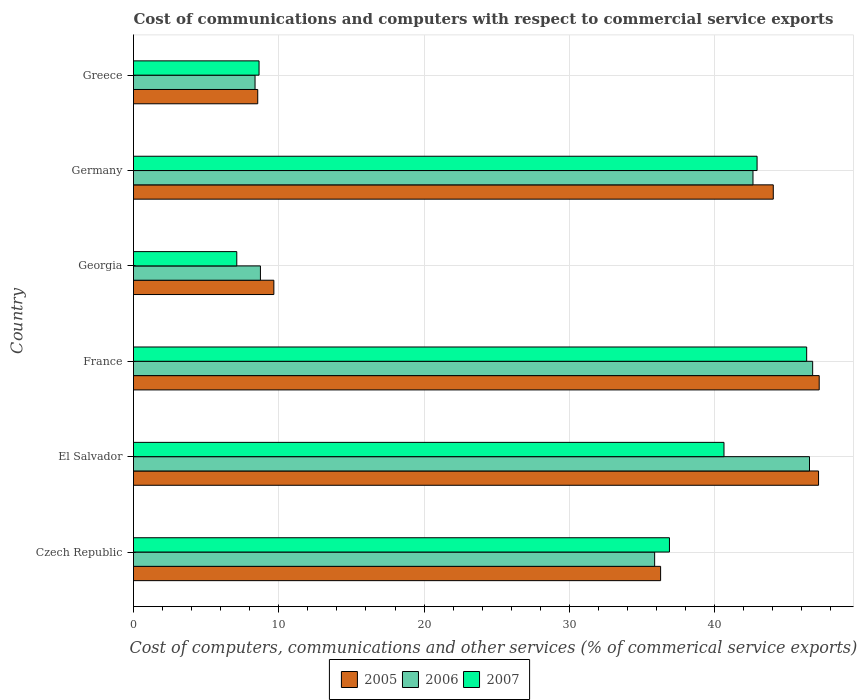Are the number of bars on each tick of the Y-axis equal?
Keep it short and to the point. Yes. How many bars are there on the 6th tick from the top?
Provide a short and direct response. 3. In how many cases, is the number of bars for a given country not equal to the number of legend labels?
Offer a very short reply. 0. What is the cost of communications and computers in 2006 in Georgia?
Your answer should be very brief. 8.74. Across all countries, what is the maximum cost of communications and computers in 2006?
Provide a succinct answer. 46.74. Across all countries, what is the minimum cost of communications and computers in 2005?
Provide a short and direct response. 8.55. In which country was the cost of communications and computers in 2006 minimum?
Your response must be concise. Greece. What is the total cost of communications and computers in 2006 in the graph?
Offer a very short reply. 188.87. What is the difference between the cost of communications and computers in 2006 in El Salvador and that in Georgia?
Provide a short and direct response. 37.79. What is the difference between the cost of communications and computers in 2006 in Greece and the cost of communications and computers in 2005 in France?
Ensure brevity in your answer.  -38.83. What is the average cost of communications and computers in 2006 per country?
Offer a terse response. 31.48. What is the difference between the cost of communications and computers in 2005 and cost of communications and computers in 2006 in Greece?
Ensure brevity in your answer.  0.19. In how many countries, is the cost of communications and computers in 2005 greater than 10 %?
Keep it short and to the point. 4. What is the ratio of the cost of communications and computers in 2006 in France to that in Greece?
Your answer should be compact. 5.59. Is the cost of communications and computers in 2006 in Czech Republic less than that in France?
Provide a succinct answer. Yes. What is the difference between the highest and the second highest cost of communications and computers in 2005?
Offer a terse response. 0.04. What is the difference between the highest and the lowest cost of communications and computers in 2005?
Make the answer very short. 38.64. Is the sum of the cost of communications and computers in 2005 in Georgia and Greece greater than the maximum cost of communications and computers in 2006 across all countries?
Your answer should be very brief. No. What does the 1st bar from the bottom in France represents?
Provide a succinct answer. 2005. How many bars are there?
Offer a very short reply. 18. How many countries are there in the graph?
Give a very brief answer. 6. What is the difference between two consecutive major ticks on the X-axis?
Your response must be concise. 10. Are the values on the major ticks of X-axis written in scientific E-notation?
Provide a succinct answer. No. Does the graph contain any zero values?
Your answer should be very brief. No. How many legend labels are there?
Your response must be concise. 3. How are the legend labels stacked?
Make the answer very short. Horizontal. What is the title of the graph?
Make the answer very short. Cost of communications and computers with respect to commercial service exports. Does "1968" appear as one of the legend labels in the graph?
Ensure brevity in your answer.  No. What is the label or title of the X-axis?
Your answer should be very brief. Cost of computers, communications and other services (% of commerical service exports). What is the Cost of computers, communications and other services (% of commerical service exports) in 2005 in Czech Republic?
Your answer should be very brief. 36.28. What is the Cost of computers, communications and other services (% of commerical service exports) in 2006 in Czech Republic?
Offer a very short reply. 35.87. What is the Cost of computers, communications and other services (% of commerical service exports) of 2007 in Czech Republic?
Give a very brief answer. 36.89. What is the Cost of computers, communications and other services (% of commerical service exports) in 2005 in El Salvador?
Offer a very short reply. 47.15. What is the Cost of computers, communications and other services (% of commerical service exports) of 2006 in El Salvador?
Give a very brief answer. 46.53. What is the Cost of computers, communications and other services (% of commerical service exports) in 2007 in El Salvador?
Give a very brief answer. 40.64. What is the Cost of computers, communications and other services (% of commerical service exports) in 2005 in France?
Offer a very short reply. 47.19. What is the Cost of computers, communications and other services (% of commerical service exports) of 2006 in France?
Your answer should be very brief. 46.74. What is the Cost of computers, communications and other services (% of commerical service exports) in 2007 in France?
Make the answer very short. 46.33. What is the Cost of computers, communications and other services (% of commerical service exports) of 2005 in Georgia?
Keep it short and to the point. 9.66. What is the Cost of computers, communications and other services (% of commerical service exports) of 2006 in Georgia?
Offer a terse response. 8.74. What is the Cost of computers, communications and other services (% of commerical service exports) of 2007 in Georgia?
Offer a terse response. 7.11. What is the Cost of computers, communications and other services (% of commerical service exports) in 2005 in Germany?
Give a very brief answer. 44.03. What is the Cost of computers, communications and other services (% of commerical service exports) in 2006 in Germany?
Keep it short and to the point. 42.64. What is the Cost of computers, communications and other services (% of commerical service exports) in 2007 in Germany?
Provide a succinct answer. 42.92. What is the Cost of computers, communications and other services (% of commerical service exports) in 2005 in Greece?
Make the answer very short. 8.55. What is the Cost of computers, communications and other services (% of commerical service exports) in 2006 in Greece?
Provide a succinct answer. 8.36. What is the Cost of computers, communications and other services (% of commerical service exports) of 2007 in Greece?
Provide a succinct answer. 8.64. Across all countries, what is the maximum Cost of computers, communications and other services (% of commerical service exports) of 2005?
Provide a succinct answer. 47.19. Across all countries, what is the maximum Cost of computers, communications and other services (% of commerical service exports) in 2006?
Give a very brief answer. 46.74. Across all countries, what is the maximum Cost of computers, communications and other services (% of commerical service exports) in 2007?
Your answer should be compact. 46.33. Across all countries, what is the minimum Cost of computers, communications and other services (% of commerical service exports) in 2005?
Give a very brief answer. 8.55. Across all countries, what is the minimum Cost of computers, communications and other services (% of commerical service exports) of 2006?
Provide a short and direct response. 8.36. Across all countries, what is the minimum Cost of computers, communications and other services (% of commerical service exports) of 2007?
Offer a very short reply. 7.11. What is the total Cost of computers, communications and other services (% of commerical service exports) of 2005 in the graph?
Ensure brevity in your answer.  192.87. What is the total Cost of computers, communications and other services (% of commerical service exports) of 2006 in the graph?
Keep it short and to the point. 188.87. What is the total Cost of computers, communications and other services (% of commerical service exports) in 2007 in the graph?
Offer a terse response. 182.53. What is the difference between the Cost of computers, communications and other services (% of commerical service exports) of 2005 in Czech Republic and that in El Salvador?
Provide a short and direct response. -10.87. What is the difference between the Cost of computers, communications and other services (% of commerical service exports) in 2006 in Czech Republic and that in El Salvador?
Your answer should be very brief. -10.66. What is the difference between the Cost of computers, communications and other services (% of commerical service exports) of 2007 in Czech Republic and that in El Salvador?
Keep it short and to the point. -3.75. What is the difference between the Cost of computers, communications and other services (% of commerical service exports) of 2005 in Czech Republic and that in France?
Give a very brief answer. -10.92. What is the difference between the Cost of computers, communications and other services (% of commerical service exports) in 2006 in Czech Republic and that in France?
Provide a succinct answer. -10.88. What is the difference between the Cost of computers, communications and other services (% of commerical service exports) of 2007 in Czech Republic and that in France?
Your answer should be compact. -9.44. What is the difference between the Cost of computers, communications and other services (% of commerical service exports) of 2005 in Czech Republic and that in Georgia?
Offer a very short reply. 26.62. What is the difference between the Cost of computers, communications and other services (% of commerical service exports) in 2006 in Czech Republic and that in Georgia?
Keep it short and to the point. 27.13. What is the difference between the Cost of computers, communications and other services (% of commerical service exports) of 2007 in Czech Republic and that in Georgia?
Provide a succinct answer. 29.78. What is the difference between the Cost of computers, communications and other services (% of commerical service exports) of 2005 in Czech Republic and that in Germany?
Offer a very short reply. -7.75. What is the difference between the Cost of computers, communications and other services (% of commerical service exports) in 2006 in Czech Republic and that in Germany?
Offer a very short reply. -6.77. What is the difference between the Cost of computers, communications and other services (% of commerical service exports) in 2007 in Czech Republic and that in Germany?
Your answer should be very brief. -6.03. What is the difference between the Cost of computers, communications and other services (% of commerical service exports) of 2005 in Czech Republic and that in Greece?
Your response must be concise. 27.73. What is the difference between the Cost of computers, communications and other services (% of commerical service exports) of 2006 in Czech Republic and that in Greece?
Your answer should be compact. 27.5. What is the difference between the Cost of computers, communications and other services (% of commerical service exports) in 2007 in Czech Republic and that in Greece?
Ensure brevity in your answer.  28.25. What is the difference between the Cost of computers, communications and other services (% of commerical service exports) of 2005 in El Salvador and that in France?
Ensure brevity in your answer.  -0.04. What is the difference between the Cost of computers, communications and other services (% of commerical service exports) in 2006 in El Salvador and that in France?
Make the answer very short. -0.22. What is the difference between the Cost of computers, communications and other services (% of commerical service exports) in 2007 in El Salvador and that in France?
Offer a terse response. -5.69. What is the difference between the Cost of computers, communications and other services (% of commerical service exports) of 2005 in El Salvador and that in Georgia?
Offer a terse response. 37.49. What is the difference between the Cost of computers, communications and other services (% of commerical service exports) in 2006 in El Salvador and that in Georgia?
Keep it short and to the point. 37.79. What is the difference between the Cost of computers, communications and other services (% of commerical service exports) in 2007 in El Salvador and that in Georgia?
Keep it short and to the point. 33.53. What is the difference between the Cost of computers, communications and other services (% of commerical service exports) in 2005 in El Salvador and that in Germany?
Give a very brief answer. 3.12. What is the difference between the Cost of computers, communications and other services (% of commerical service exports) of 2006 in El Salvador and that in Germany?
Your response must be concise. 3.89. What is the difference between the Cost of computers, communications and other services (% of commerical service exports) of 2007 in El Salvador and that in Germany?
Your answer should be compact. -2.28. What is the difference between the Cost of computers, communications and other services (% of commerical service exports) of 2005 in El Salvador and that in Greece?
Provide a succinct answer. 38.6. What is the difference between the Cost of computers, communications and other services (% of commerical service exports) in 2006 in El Salvador and that in Greece?
Your answer should be very brief. 38.16. What is the difference between the Cost of computers, communications and other services (% of commerical service exports) in 2007 in El Salvador and that in Greece?
Keep it short and to the point. 32. What is the difference between the Cost of computers, communications and other services (% of commerical service exports) in 2005 in France and that in Georgia?
Provide a succinct answer. 37.53. What is the difference between the Cost of computers, communications and other services (% of commerical service exports) in 2006 in France and that in Georgia?
Your answer should be compact. 38.01. What is the difference between the Cost of computers, communications and other services (% of commerical service exports) of 2007 in France and that in Georgia?
Ensure brevity in your answer.  39.22. What is the difference between the Cost of computers, communications and other services (% of commerical service exports) in 2005 in France and that in Germany?
Give a very brief answer. 3.16. What is the difference between the Cost of computers, communications and other services (% of commerical service exports) of 2006 in France and that in Germany?
Provide a short and direct response. 4.11. What is the difference between the Cost of computers, communications and other services (% of commerical service exports) in 2007 in France and that in Germany?
Your response must be concise. 3.41. What is the difference between the Cost of computers, communications and other services (% of commerical service exports) of 2005 in France and that in Greece?
Offer a very short reply. 38.64. What is the difference between the Cost of computers, communications and other services (% of commerical service exports) of 2006 in France and that in Greece?
Your answer should be compact. 38.38. What is the difference between the Cost of computers, communications and other services (% of commerical service exports) of 2007 in France and that in Greece?
Provide a short and direct response. 37.69. What is the difference between the Cost of computers, communications and other services (% of commerical service exports) in 2005 in Georgia and that in Germany?
Offer a terse response. -34.37. What is the difference between the Cost of computers, communications and other services (% of commerical service exports) of 2006 in Georgia and that in Germany?
Provide a succinct answer. -33.9. What is the difference between the Cost of computers, communications and other services (% of commerical service exports) of 2007 in Georgia and that in Germany?
Give a very brief answer. -35.81. What is the difference between the Cost of computers, communications and other services (% of commerical service exports) of 2005 in Georgia and that in Greece?
Your response must be concise. 1.11. What is the difference between the Cost of computers, communications and other services (% of commerical service exports) in 2006 in Georgia and that in Greece?
Keep it short and to the point. 0.37. What is the difference between the Cost of computers, communications and other services (% of commerical service exports) of 2007 in Georgia and that in Greece?
Ensure brevity in your answer.  -1.53. What is the difference between the Cost of computers, communications and other services (% of commerical service exports) of 2005 in Germany and that in Greece?
Keep it short and to the point. 35.48. What is the difference between the Cost of computers, communications and other services (% of commerical service exports) of 2006 in Germany and that in Greece?
Offer a terse response. 34.27. What is the difference between the Cost of computers, communications and other services (% of commerical service exports) in 2007 in Germany and that in Greece?
Give a very brief answer. 34.28. What is the difference between the Cost of computers, communications and other services (% of commerical service exports) in 2005 in Czech Republic and the Cost of computers, communications and other services (% of commerical service exports) in 2006 in El Salvador?
Make the answer very short. -10.25. What is the difference between the Cost of computers, communications and other services (% of commerical service exports) of 2005 in Czech Republic and the Cost of computers, communications and other services (% of commerical service exports) of 2007 in El Salvador?
Offer a very short reply. -4.36. What is the difference between the Cost of computers, communications and other services (% of commerical service exports) of 2006 in Czech Republic and the Cost of computers, communications and other services (% of commerical service exports) of 2007 in El Salvador?
Offer a very short reply. -4.77. What is the difference between the Cost of computers, communications and other services (% of commerical service exports) in 2005 in Czech Republic and the Cost of computers, communications and other services (% of commerical service exports) in 2006 in France?
Your response must be concise. -10.46. What is the difference between the Cost of computers, communications and other services (% of commerical service exports) of 2005 in Czech Republic and the Cost of computers, communications and other services (% of commerical service exports) of 2007 in France?
Your answer should be very brief. -10.05. What is the difference between the Cost of computers, communications and other services (% of commerical service exports) of 2006 in Czech Republic and the Cost of computers, communications and other services (% of commerical service exports) of 2007 in France?
Your answer should be very brief. -10.46. What is the difference between the Cost of computers, communications and other services (% of commerical service exports) in 2005 in Czech Republic and the Cost of computers, communications and other services (% of commerical service exports) in 2006 in Georgia?
Make the answer very short. 27.54. What is the difference between the Cost of computers, communications and other services (% of commerical service exports) in 2005 in Czech Republic and the Cost of computers, communications and other services (% of commerical service exports) in 2007 in Georgia?
Make the answer very short. 29.17. What is the difference between the Cost of computers, communications and other services (% of commerical service exports) in 2006 in Czech Republic and the Cost of computers, communications and other services (% of commerical service exports) in 2007 in Georgia?
Provide a succinct answer. 28.76. What is the difference between the Cost of computers, communications and other services (% of commerical service exports) in 2005 in Czech Republic and the Cost of computers, communications and other services (% of commerical service exports) in 2006 in Germany?
Ensure brevity in your answer.  -6.36. What is the difference between the Cost of computers, communications and other services (% of commerical service exports) in 2005 in Czech Republic and the Cost of computers, communications and other services (% of commerical service exports) in 2007 in Germany?
Provide a short and direct response. -6.64. What is the difference between the Cost of computers, communications and other services (% of commerical service exports) of 2006 in Czech Republic and the Cost of computers, communications and other services (% of commerical service exports) of 2007 in Germany?
Your answer should be very brief. -7.05. What is the difference between the Cost of computers, communications and other services (% of commerical service exports) in 2005 in Czech Republic and the Cost of computers, communications and other services (% of commerical service exports) in 2006 in Greece?
Provide a short and direct response. 27.91. What is the difference between the Cost of computers, communications and other services (% of commerical service exports) in 2005 in Czech Republic and the Cost of computers, communications and other services (% of commerical service exports) in 2007 in Greece?
Provide a short and direct response. 27.64. What is the difference between the Cost of computers, communications and other services (% of commerical service exports) of 2006 in Czech Republic and the Cost of computers, communications and other services (% of commerical service exports) of 2007 in Greece?
Your response must be concise. 27.23. What is the difference between the Cost of computers, communications and other services (% of commerical service exports) of 2005 in El Salvador and the Cost of computers, communications and other services (% of commerical service exports) of 2006 in France?
Offer a very short reply. 0.41. What is the difference between the Cost of computers, communications and other services (% of commerical service exports) of 2005 in El Salvador and the Cost of computers, communications and other services (% of commerical service exports) of 2007 in France?
Provide a succinct answer. 0.82. What is the difference between the Cost of computers, communications and other services (% of commerical service exports) of 2006 in El Salvador and the Cost of computers, communications and other services (% of commerical service exports) of 2007 in France?
Ensure brevity in your answer.  0.19. What is the difference between the Cost of computers, communications and other services (% of commerical service exports) in 2005 in El Salvador and the Cost of computers, communications and other services (% of commerical service exports) in 2006 in Georgia?
Ensure brevity in your answer.  38.41. What is the difference between the Cost of computers, communications and other services (% of commerical service exports) in 2005 in El Salvador and the Cost of computers, communications and other services (% of commerical service exports) in 2007 in Georgia?
Keep it short and to the point. 40.04. What is the difference between the Cost of computers, communications and other services (% of commerical service exports) of 2006 in El Salvador and the Cost of computers, communications and other services (% of commerical service exports) of 2007 in Georgia?
Offer a terse response. 39.42. What is the difference between the Cost of computers, communications and other services (% of commerical service exports) of 2005 in El Salvador and the Cost of computers, communications and other services (% of commerical service exports) of 2006 in Germany?
Your answer should be very brief. 4.51. What is the difference between the Cost of computers, communications and other services (% of commerical service exports) in 2005 in El Salvador and the Cost of computers, communications and other services (% of commerical service exports) in 2007 in Germany?
Ensure brevity in your answer.  4.23. What is the difference between the Cost of computers, communications and other services (% of commerical service exports) of 2006 in El Salvador and the Cost of computers, communications and other services (% of commerical service exports) of 2007 in Germany?
Your answer should be very brief. 3.61. What is the difference between the Cost of computers, communications and other services (% of commerical service exports) of 2005 in El Salvador and the Cost of computers, communications and other services (% of commerical service exports) of 2006 in Greece?
Offer a very short reply. 38.78. What is the difference between the Cost of computers, communications and other services (% of commerical service exports) of 2005 in El Salvador and the Cost of computers, communications and other services (% of commerical service exports) of 2007 in Greece?
Your answer should be compact. 38.51. What is the difference between the Cost of computers, communications and other services (% of commerical service exports) of 2006 in El Salvador and the Cost of computers, communications and other services (% of commerical service exports) of 2007 in Greece?
Your response must be concise. 37.89. What is the difference between the Cost of computers, communications and other services (% of commerical service exports) of 2005 in France and the Cost of computers, communications and other services (% of commerical service exports) of 2006 in Georgia?
Your response must be concise. 38.46. What is the difference between the Cost of computers, communications and other services (% of commerical service exports) of 2005 in France and the Cost of computers, communications and other services (% of commerical service exports) of 2007 in Georgia?
Make the answer very short. 40.09. What is the difference between the Cost of computers, communications and other services (% of commerical service exports) of 2006 in France and the Cost of computers, communications and other services (% of commerical service exports) of 2007 in Georgia?
Your answer should be very brief. 39.64. What is the difference between the Cost of computers, communications and other services (% of commerical service exports) of 2005 in France and the Cost of computers, communications and other services (% of commerical service exports) of 2006 in Germany?
Your response must be concise. 4.56. What is the difference between the Cost of computers, communications and other services (% of commerical service exports) in 2005 in France and the Cost of computers, communications and other services (% of commerical service exports) in 2007 in Germany?
Ensure brevity in your answer.  4.28. What is the difference between the Cost of computers, communications and other services (% of commerical service exports) in 2006 in France and the Cost of computers, communications and other services (% of commerical service exports) in 2007 in Germany?
Offer a very short reply. 3.83. What is the difference between the Cost of computers, communications and other services (% of commerical service exports) of 2005 in France and the Cost of computers, communications and other services (% of commerical service exports) of 2006 in Greece?
Make the answer very short. 38.83. What is the difference between the Cost of computers, communications and other services (% of commerical service exports) in 2005 in France and the Cost of computers, communications and other services (% of commerical service exports) in 2007 in Greece?
Your answer should be compact. 38.55. What is the difference between the Cost of computers, communications and other services (% of commerical service exports) in 2006 in France and the Cost of computers, communications and other services (% of commerical service exports) in 2007 in Greece?
Keep it short and to the point. 38.1. What is the difference between the Cost of computers, communications and other services (% of commerical service exports) of 2005 in Georgia and the Cost of computers, communications and other services (% of commerical service exports) of 2006 in Germany?
Ensure brevity in your answer.  -32.98. What is the difference between the Cost of computers, communications and other services (% of commerical service exports) of 2005 in Georgia and the Cost of computers, communications and other services (% of commerical service exports) of 2007 in Germany?
Your answer should be very brief. -33.26. What is the difference between the Cost of computers, communications and other services (% of commerical service exports) of 2006 in Georgia and the Cost of computers, communications and other services (% of commerical service exports) of 2007 in Germany?
Make the answer very short. -34.18. What is the difference between the Cost of computers, communications and other services (% of commerical service exports) of 2005 in Georgia and the Cost of computers, communications and other services (% of commerical service exports) of 2006 in Greece?
Your response must be concise. 1.3. What is the difference between the Cost of computers, communications and other services (% of commerical service exports) of 2005 in Georgia and the Cost of computers, communications and other services (% of commerical service exports) of 2007 in Greece?
Make the answer very short. 1.02. What is the difference between the Cost of computers, communications and other services (% of commerical service exports) of 2006 in Georgia and the Cost of computers, communications and other services (% of commerical service exports) of 2007 in Greece?
Your response must be concise. 0.1. What is the difference between the Cost of computers, communications and other services (% of commerical service exports) in 2005 in Germany and the Cost of computers, communications and other services (% of commerical service exports) in 2006 in Greece?
Make the answer very short. 35.67. What is the difference between the Cost of computers, communications and other services (% of commerical service exports) of 2005 in Germany and the Cost of computers, communications and other services (% of commerical service exports) of 2007 in Greece?
Your response must be concise. 35.39. What is the difference between the Cost of computers, communications and other services (% of commerical service exports) in 2006 in Germany and the Cost of computers, communications and other services (% of commerical service exports) in 2007 in Greece?
Provide a short and direct response. 34. What is the average Cost of computers, communications and other services (% of commerical service exports) of 2005 per country?
Ensure brevity in your answer.  32.14. What is the average Cost of computers, communications and other services (% of commerical service exports) of 2006 per country?
Offer a terse response. 31.48. What is the average Cost of computers, communications and other services (% of commerical service exports) of 2007 per country?
Make the answer very short. 30.42. What is the difference between the Cost of computers, communications and other services (% of commerical service exports) of 2005 and Cost of computers, communications and other services (% of commerical service exports) of 2006 in Czech Republic?
Provide a short and direct response. 0.41. What is the difference between the Cost of computers, communications and other services (% of commerical service exports) in 2005 and Cost of computers, communications and other services (% of commerical service exports) in 2007 in Czech Republic?
Your answer should be compact. -0.61. What is the difference between the Cost of computers, communications and other services (% of commerical service exports) in 2006 and Cost of computers, communications and other services (% of commerical service exports) in 2007 in Czech Republic?
Your response must be concise. -1.02. What is the difference between the Cost of computers, communications and other services (% of commerical service exports) in 2005 and Cost of computers, communications and other services (% of commerical service exports) in 2006 in El Salvador?
Your response must be concise. 0.62. What is the difference between the Cost of computers, communications and other services (% of commerical service exports) of 2005 and Cost of computers, communications and other services (% of commerical service exports) of 2007 in El Salvador?
Offer a very short reply. 6.51. What is the difference between the Cost of computers, communications and other services (% of commerical service exports) in 2006 and Cost of computers, communications and other services (% of commerical service exports) in 2007 in El Salvador?
Offer a very short reply. 5.89. What is the difference between the Cost of computers, communications and other services (% of commerical service exports) in 2005 and Cost of computers, communications and other services (% of commerical service exports) in 2006 in France?
Give a very brief answer. 0.45. What is the difference between the Cost of computers, communications and other services (% of commerical service exports) of 2005 and Cost of computers, communications and other services (% of commerical service exports) of 2007 in France?
Your answer should be compact. 0.86. What is the difference between the Cost of computers, communications and other services (% of commerical service exports) in 2006 and Cost of computers, communications and other services (% of commerical service exports) in 2007 in France?
Offer a terse response. 0.41. What is the difference between the Cost of computers, communications and other services (% of commerical service exports) in 2005 and Cost of computers, communications and other services (% of commerical service exports) in 2006 in Georgia?
Provide a succinct answer. 0.93. What is the difference between the Cost of computers, communications and other services (% of commerical service exports) of 2005 and Cost of computers, communications and other services (% of commerical service exports) of 2007 in Georgia?
Ensure brevity in your answer.  2.55. What is the difference between the Cost of computers, communications and other services (% of commerical service exports) of 2006 and Cost of computers, communications and other services (% of commerical service exports) of 2007 in Georgia?
Ensure brevity in your answer.  1.63. What is the difference between the Cost of computers, communications and other services (% of commerical service exports) of 2005 and Cost of computers, communications and other services (% of commerical service exports) of 2006 in Germany?
Keep it short and to the point. 1.4. What is the difference between the Cost of computers, communications and other services (% of commerical service exports) of 2005 and Cost of computers, communications and other services (% of commerical service exports) of 2007 in Germany?
Offer a terse response. 1.11. What is the difference between the Cost of computers, communications and other services (% of commerical service exports) of 2006 and Cost of computers, communications and other services (% of commerical service exports) of 2007 in Germany?
Your answer should be compact. -0.28. What is the difference between the Cost of computers, communications and other services (% of commerical service exports) in 2005 and Cost of computers, communications and other services (% of commerical service exports) in 2006 in Greece?
Your response must be concise. 0.19. What is the difference between the Cost of computers, communications and other services (% of commerical service exports) in 2005 and Cost of computers, communications and other services (% of commerical service exports) in 2007 in Greece?
Ensure brevity in your answer.  -0.09. What is the difference between the Cost of computers, communications and other services (% of commerical service exports) of 2006 and Cost of computers, communications and other services (% of commerical service exports) of 2007 in Greece?
Give a very brief answer. -0.28. What is the ratio of the Cost of computers, communications and other services (% of commerical service exports) of 2005 in Czech Republic to that in El Salvador?
Provide a succinct answer. 0.77. What is the ratio of the Cost of computers, communications and other services (% of commerical service exports) of 2006 in Czech Republic to that in El Salvador?
Ensure brevity in your answer.  0.77. What is the ratio of the Cost of computers, communications and other services (% of commerical service exports) of 2007 in Czech Republic to that in El Salvador?
Provide a short and direct response. 0.91. What is the ratio of the Cost of computers, communications and other services (% of commerical service exports) in 2005 in Czech Republic to that in France?
Your response must be concise. 0.77. What is the ratio of the Cost of computers, communications and other services (% of commerical service exports) of 2006 in Czech Republic to that in France?
Offer a terse response. 0.77. What is the ratio of the Cost of computers, communications and other services (% of commerical service exports) in 2007 in Czech Republic to that in France?
Make the answer very short. 0.8. What is the ratio of the Cost of computers, communications and other services (% of commerical service exports) in 2005 in Czech Republic to that in Georgia?
Give a very brief answer. 3.76. What is the ratio of the Cost of computers, communications and other services (% of commerical service exports) of 2006 in Czech Republic to that in Georgia?
Ensure brevity in your answer.  4.11. What is the ratio of the Cost of computers, communications and other services (% of commerical service exports) of 2007 in Czech Republic to that in Georgia?
Your response must be concise. 5.19. What is the ratio of the Cost of computers, communications and other services (% of commerical service exports) of 2005 in Czech Republic to that in Germany?
Keep it short and to the point. 0.82. What is the ratio of the Cost of computers, communications and other services (% of commerical service exports) in 2006 in Czech Republic to that in Germany?
Provide a short and direct response. 0.84. What is the ratio of the Cost of computers, communications and other services (% of commerical service exports) in 2007 in Czech Republic to that in Germany?
Keep it short and to the point. 0.86. What is the ratio of the Cost of computers, communications and other services (% of commerical service exports) of 2005 in Czech Republic to that in Greece?
Give a very brief answer. 4.24. What is the ratio of the Cost of computers, communications and other services (% of commerical service exports) of 2006 in Czech Republic to that in Greece?
Provide a short and direct response. 4.29. What is the ratio of the Cost of computers, communications and other services (% of commerical service exports) of 2007 in Czech Republic to that in Greece?
Provide a succinct answer. 4.27. What is the ratio of the Cost of computers, communications and other services (% of commerical service exports) in 2005 in El Salvador to that in France?
Offer a terse response. 1. What is the ratio of the Cost of computers, communications and other services (% of commerical service exports) of 2006 in El Salvador to that in France?
Offer a very short reply. 1. What is the ratio of the Cost of computers, communications and other services (% of commerical service exports) of 2007 in El Salvador to that in France?
Give a very brief answer. 0.88. What is the ratio of the Cost of computers, communications and other services (% of commerical service exports) of 2005 in El Salvador to that in Georgia?
Offer a very short reply. 4.88. What is the ratio of the Cost of computers, communications and other services (% of commerical service exports) of 2006 in El Salvador to that in Georgia?
Provide a succinct answer. 5.33. What is the ratio of the Cost of computers, communications and other services (% of commerical service exports) of 2007 in El Salvador to that in Georgia?
Your answer should be compact. 5.72. What is the ratio of the Cost of computers, communications and other services (% of commerical service exports) of 2005 in El Salvador to that in Germany?
Your answer should be very brief. 1.07. What is the ratio of the Cost of computers, communications and other services (% of commerical service exports) of 2006 in El Salvador to that in Germany?
Provide a short and direct response. 1.09. What is the ratio of the Cost of computers, communications and other services (% of commerical service exports) of 2007 in El Salvador to that in Germany?
Offer a very short reply. 0.95. What is the ratio of the Cost of computers, communications and other services (% of commerical service exports) of 2005 in El Salvador to that in Greece?
Ensure brevity in your answer.  5.51. What is the ratio of the Cost of computers, communications and other services (% of commerical service exports) of 2006 in El Salvador to that in Greece?
Offer a terse response. 5.56. What is the ratio of the Cost of computers, communications and other services (% of commerical service exports) in 2007 in El Salvador to that in Greece?
Offer a terse response. 4.7. What is the ratio of the Cost of computers, communications and other services (% of commerical service exports) in 2005 in France to that in Georgia?
Your answer should be compact. 4.89. What is the ratio of the Cost of computers, communications and other services (% of commerical service exports) of 2006 in France to that in Georgia?
Provide a succinct answer. 5.35. What is the ratio of the Cost of computers, communications and other services (% of commerical service exports) in 2007 in France to that in Georgia?
Give a very brief answer. 6.52. What is the ratio of the Cost of computers, communications and other services (% of commerical service exports) of 2005 in France to that in Germany?
Keep it short and to the point. 1.07. What is the ratio of the Cost of computers, communications and other services (% of commerical service exports) in 2006 in France to that in Germany?
Keep it short and to the point. 1.1. What is the ratio of the Cost of computers, communications and other services (% of commerical service exports) in 2007 in France to that in Germany?
Your answer should be compact. 1.08. What is the ratio of the Cost of computers, communications and other services (% of commerical service exports) in 2005 in France to that in Greece?
Offer a very short reply. 5.52. What is the ratio of the Cost of computers, communications and other services (% of commerical service exports) in 2006 in France to that in Greece?
Keep it short and to the point. 5.59. What is the ratio of the Cost of computers, communications and other services (% of commerical service exports) of 2007 in France to that in Greece?
Give a very brief answer. 5.36. What is the ratio of the Cost of computers, communications and other services (% of commerical service exports) of 2005 in Georgia to that in Germany?
Keep it short and to the point. 0.22. What is the ratio of the Cost of computers, communications and other services (% of commerical service exports) of 2006 in Georgia to that in Germany?
Your response must be concise. 0.2. What is the ratio of the Cost of computers, communications and other services (% of commerical service exports) in 2007 in Georgia to that in Germany?
Give a very brief answer. 0.17. What is the ratio of the Cost of computers, communications and other services (% of commerical service exports) in 2005 in Georgia to that in Greece?
Offer a terse response. 1.13. What is the ratio of the Cost of computers, communications and other services (% of commerical service exports) in 2006 in Georgia to that in Greece?
Your response must be concise. 1.04. What is the ratio of the Cost of computers, communications and other services (% of commerical service exports) of 2007 in Georgia to that in Greece?
Ensure brevity in your answer.  0.82. What is the ratio of the Cost of computers, communications and other services (% of commerical service exports) in 2005 in Germany to that in Greece?
Offer a terse response. 5.15. What is the ratio of the Cost of computers, communications and other services (% of commerical service exports) in 2006 in Germany to that in Greece?
Offer a terse response. 5.1. What is the ratio of the Cost of computers, communications and other services (% of commerical service exports) in 2007 in Germany to that in Greece?
Give a very brief answer. 4.97. What is the difference between the highest and the second highest Cost of computers, communications and other services (% of commerical service exports) in 2005?
Provide a short and direct response. 0.04. What is the difference between the highest and the second highest Cost of computers, communications and other services (% of commerical service exports) in 2006?
Ensure brevity in your answer.  0.22. What is the difference between the highest and the second highest Cost of computers, communications and other services (% of commerical service exports) in 2007?
Keep it short and to the point. 3.41. What is the difference between the highest and the lowest Cost of computers, communications and other services (% of commerical service exports) in 2005?
Offer a terse response. 38.64. What is the difference between the highest and the lowest Cost of computers, communications and other services (% of commerical service exports) of 2006?
Provide a succinct answer. 38.38. What is the difference between the highest and the lowest Cost of computers, communications and other services (% of commerical service exports) in 2007?
Ensure brevity in your answer.  39.22. 